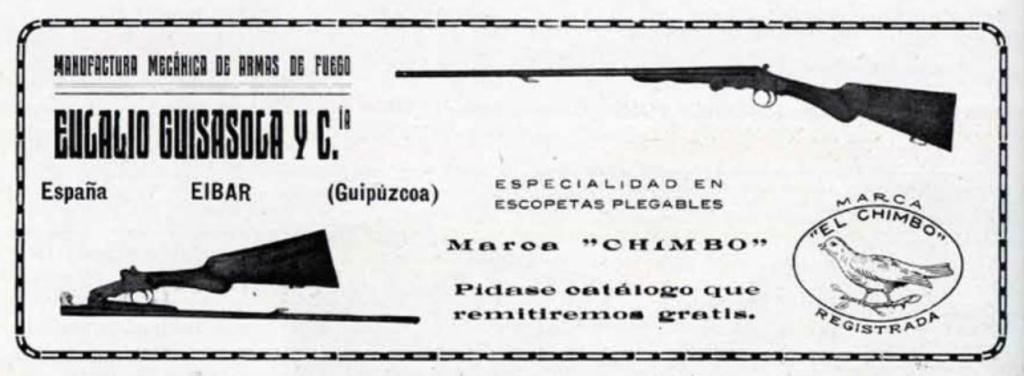What objects are present in the image? There are two guns in the image. What can be found below the guns? There is writing below the guns. What can be found above the guns? There is writing above the guns. What type of hat is being worn by the person at the meeting in the image? There is no person or meeting present in the image; it only features two guns and writing. 